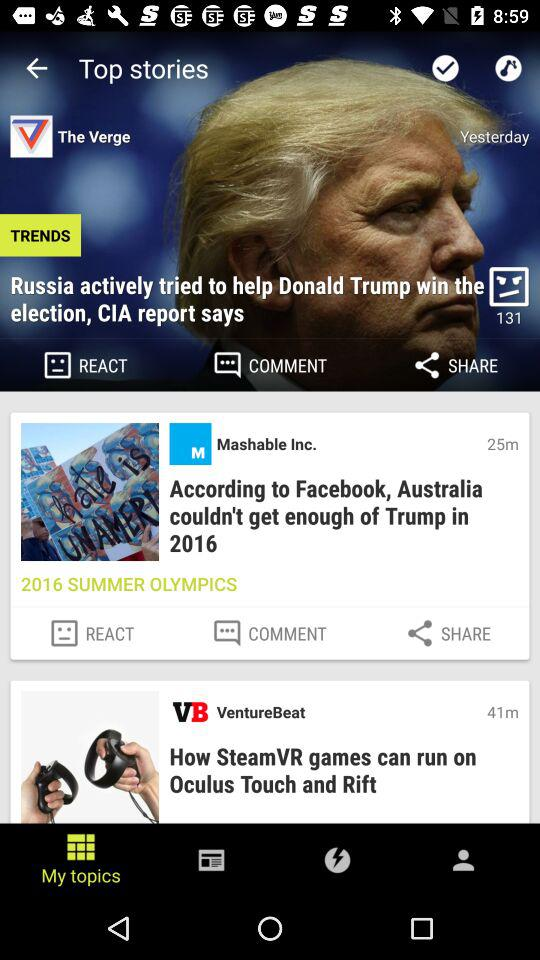Which is the selected tab? The selected tab is "My topics". 